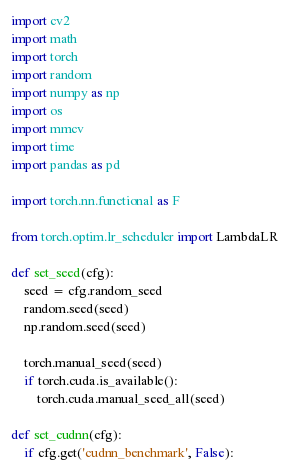Convert code to text. <code><loc_0><loc_0><loc_500><loc_500><_Python_>import cv2
import math
import torch
import random
import numpy as np
import os
import mmcv
import time
import pandas as pd

import torch.nn.functional as F

from torch.optim.lr_scheduler import LambdaLR

def set_seed(cfg):
    seed = cfg.random_seed
    random.seed(seed)
    np.random.seed(seed)

    torch.manual_seed(seed)
    if torch.cuda.is_available():
        torch.cuda.manual_seed_all(seed)

def set_cudnn(cfg):
    if cfg.get('cudnn_benchmark', False):</code> 